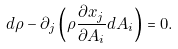Convert formula to latex. <formula><loc_0><loc_0><loc_500><loc_500>d \rho - \partial _ { j } \left ( \rho \frac { \partial x _ { j } } { \partial A _ { i } } d A _ { i } \right ) = 0 .</formula> 